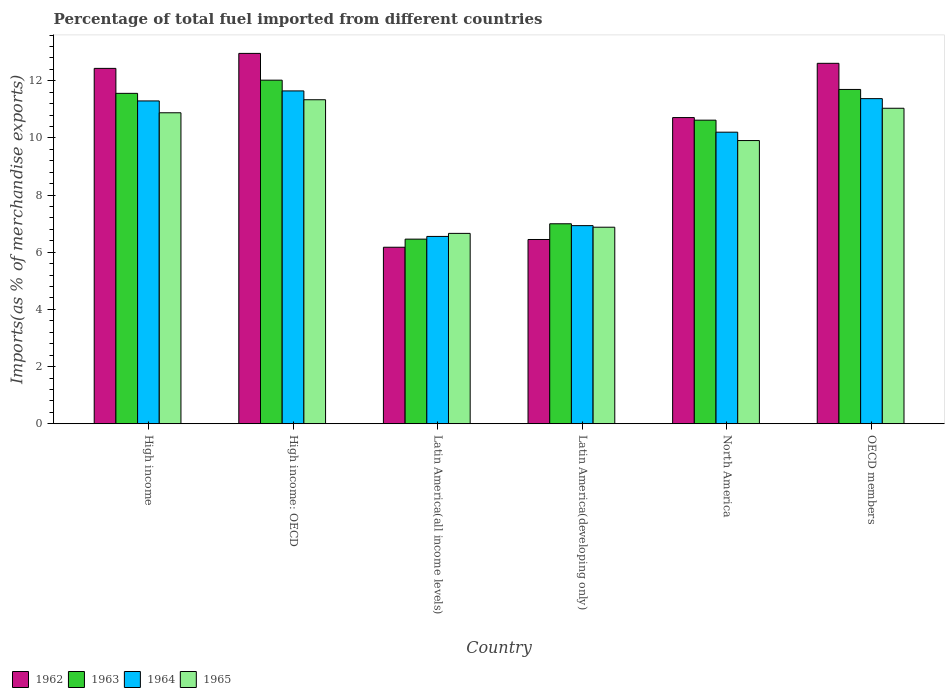Are the number of bars per tick equal to the number of legend labels?
Provide a short and direct response. Yes. How many bars are there on the 6th tick from the left?
Your answer should be compact. 4. How many bars are there on the 4th tick from the right?
Make the answer very short. 4. What is the percentage of imports to different countries in 1964 in High income?
Make the answer very short. 11.29. Across all countries, what is the maximum percentage of imports to different countries in 1964?
Give a very brief answer. 11.64. Across all countries, what is the minimum percentage of imports to different countries in 1962?
Offer a very short reply. 6.17. In which country was the percentage of imports to different countries in 1962 maximum?
Keep it short and to the point. High income: OECD. In which country was the percentage of imports to different countries in 1965 minimum?
Your answer should be compact. Latin America(all income levels). What is the total percentage of imports to different countries in 1963 in the graph?
Your answer should be very brief. 59.35. What is the difference between the percentage of imports to different countries in 1962 in Latin America(all income levels) and that in OECD members?
Your response must be concise. -6.44. What is the difference between the percentage of imports to different countries in 1965 in Latin America(all income levels) and the percentage of imports to different countries in 1962 in OECD members?
Offer a terse response. -5.95. What is the average percentage of imports to different countries in 1962 per country?
Give a very brief answer. 10.22. What is the difference between the percentage of imports to different countries of/in 1963 and percentage of imports to different countries of/in 1965 in OECD members?
Your response must be concise. 0.66. In how many countries, is the percentage of imports to different countries in 1963 greater than 4.8 %?
Your answer should be very brief. 6. What is the ratio of the percentage of imports to different countries in 1963 in Latin America(developing only) to that in North America?
Offer a very short reply. 0.66. Is the difference between the percentage of imports to different countries in 1963 in Latin America(all income levels) and Latin America(developing only) greater than the difference between the percentage of imports to different countries in 1965 in Latin America(all income levels) and Latin America(developing only)?
Offer a very short reply. No. What is the difference between the highest and the second highest percentage of imports to different countries in 1964?
Provide a short and direct response. -0.27. What is the difference between the highest and the lowest percentage of imports to different countries in 1964?
Your response must be concise. 5.09. Is the sum of the percentage of imports to different countries in 1963 in High income: OECD and OECD members greater than the maximum percentage of imports to different countries in 1965 across all countries?
Provide a short and direct response. Yes. Is it the case that in every country, the sum of the percentage of imports to different countries in 1964 and percentage of imports to different countries in 1962 is greater than the sum of percentage of imports to different countries in 1965 and percentage of imports to different countries in 1963?
Keep it short and to the point. No. What does the 2nd bar from the right in Latin America(all income levels) represents?
Provide a succinct answer. 1964. How many countries are there in the graph?
Provide a short and direct response. 6. Are the values on the major ticks of Y-axis written in scientific E-notation?
Offer a very short reply. No. Does the graph contain any zero values?
Offer a very short reply. No. Where does the legend appear in the graph?
Ensure brevity in your answer.  Bottom left. How many legend labels are there?
Give a very brief answer. 4. What is the title of the graph?
Your response must be concise. Percentage of total fuel imported from different countries. Does "1967" appear as one of the legend labels in the graph?
Offer a terse response. No. What is the label or title of the X-axis?
Provide a succinct answer. Country. What is the label or title of the Y-axis?
Provide a short and direct response. Imports(as % of merchandise exports). What is the Imports(as % of merchandise exports) in 1962 in High income?
Offer a terse response. 12.43. What is the Imports(as % of merchandise exports) in 1963 in High income?
Your answer should be very brief. 11.56. What is the Imports(as % of merchandise exports) of 1964 in High income?
Keep it short and to the point. 11.29. What is the Imports(as % of merchandise exports) of 1965 in High income?
Your answer should be compact. 10.88. What is the Imports(as % of merchandise exports) in 1962 in High income: OECD?
Provide a succinct answer. 12.96. What is the Imports(as % of merchandise exports) in 1963 in High income: OECD?
Keep it short and to the point. 12.02. What is the Imports(as % of merchandise exports) of 1964 in High income: OECD?
Make the answer very short. 11.64. What is the Imports(as % of merchandise exports) in 1965 in High income: OECD?
Make the answer very short. 11.34. What is the Imports(as % of merchandise exports) in 1962 in Latin America(all income levels)?
Provide a succinct answer. 6.17. What is the Imports(as % of merchandise exports) of 1963 in Latin America(all income levels)?
Provide a short and direct response. 6.46. What is the Imports(as % of merchandise exports) in 1964 in Latin America(all income levels)?
Give a very brief answer. 6.55. What is the Imports(as % of merchandise exports) in 1965 in Latin America(all income levels)?
Your response must be concise. 6.66. What is the Imports(as % of merchandise exports) of 1962 in Latin America(developing only)?
Keep it short and to the point. 6.45. What is the Imports(as % of merchandise exports) of 1963 in Latin America(developing only)?
Offer a terse response. 7. What is the Imports(as % of merchandise exports) in 1964 in Latin America(developing only)?
Your answer should be compact. 6.93. What is the Imports(as % of merchandise exports) of 1965 in Latin America(developing only)?
Provide a succinct answer. 6.88. What is the Imports(as % of merchandise exports) of 1962 in North America?
Your answer should be compact. 10.71. What is the Imports(as % of merchandise exports) of 1963 in North America?
Offer a terse response. 10.62. What is the Imports(as % of merchandise exports) of 1964 in North America?
Offer a terse response. 10.2. What is the Imports(as % of merchandise exports) of 1965 in North America?
Your answer should be compact. 9.91. What is the Imports(as % of merchandise exports) in 1962 in OECD members?
Ensure brevity in your answer.  12.61. What is the Imports(as % of merchandise exports) of 1963 in OECD members?
Your response must be concise. 11.7. What is the Imports(as % of merchandise exports) of 1964 in OECD members?
Provide a succinct answer. 11.37. What is the Imports(as % of merchandise exports) of 1965 in OECD members?
Your response must be concise. 11.04. Across all countries, what is the maximum Imports(as % of merchandise exports) of 1962?
Your response must be concise. 12.96. Across all countries, what is the maximum Imports(as % of merchandise exports) in 1963?
Provide a succinct answer. 12.02. Across all countries, what is the maximum Imports(as % of merchandise exports) in 1964?
Provide a short and direct response. 11.64. Across all countries, what is the maximum Imports(as % of merchandise exports) of 1965?
Your answer should be very brief. 11.34. Across all countries, what is the minimum Imports(as % of merchandise exports) in 1962?
Give a very brief answer. 6.17. Across all countries, what is the minimum Imports(as % of merchandise exports) of 1963?
Your answer should be very brief. 6.46. Across all countries, what is the minimum Imports(as % of merchandise exports) in 1964?
Offer a very short reply. 6.55. Across all countries, what is the minimum Imports(as % of merchandise exports) in 1965?
Provide a short and direct response. 6.66. What is the total Imports(as % of merchandise exports) of 1962 in the graph?
Provide a short and direct response. 61.33. What is the total Imports(as % of merchandise exports) in 1963 in the graph?
Your answer should be very brief. 59.35. What is the total Imports(as % of merchandise exports) of 1964 in the graph?
Your response must be concise. 58. What is the total Imports(as % of merchandise exports) of 1965 in the graph?
Provide a succinct answer. 56.7. What is the difference between the Imports(as % of merchandise exports) of 1962 in High income and that in High income: OECD?
Provide a short and direct response. -0.52. What is the difference between the Imports(as % of merchandise exports) of 1963 in High income and that in High income: OECD?
Make the answer very short. -0.46. What is the difference between the Imports(as % of merchandise exports) in 1964 in High income and that in High income: OECD?
Make the answer very short. -0.35. What is the difference between the Imports(as % of merchandise exports) of 1965 in High income and that in High income: OECD?
Offer a terse response. -0.46. What is the difference between the Imports(as % of merchandise exports) of 1962 in High income and that in Latin America(all income levels)?
Keep it short and to the point. 6.26. What is the difference between the Imports(as % of merchandise exports) of 1963 in High income and that in Latin America(all income levels)?
Your response must be concise. 5.1. What is the difference between the Imports(as % of merchandise exports) of 1964 in High income and that in Latin America(all income levels)?
Provide a succinct answer. 4.74. What is the difference between the Imports(as % of merchandise exports) of 1965 in High income and that in Latin America(all income levels)?
Make the answer very short. 4.22. What is the difference between the Imports(as % of merchandise exports) of 1962 in High income and that in Latin America(developing only)?
Provide a succinct answer. 5.99. What is the difference between the Imports(as % of merchandise exports) of 1963 in High income and that in Latin America(developing only)?
Keep it short and to the point. 4.56. What is the difference between the Imports(as % of merchandise exports) in 1964 in High income and that in Latin America(developing only)?
Make the answer very short. 4.36. What is the difference between the Imports(as % of merchandise exports) of 1965 in High income and that in Latin America(developing only)?
Your answer should be compact. 4. What is the difference between the Imports(as % of merchandise exports) of 1962 in High income and that in North America?
Provide a short and direct response. 1.72. What is the difference between the Imports(as % of merchandise exports) of 1963 in High income and that in North America?
Provide a short and direct response. 0.94. What is the difference between the Imports(as % of merchandise exports) in 1964 in High income and that in North America?
Your response must be concise. 1.09. What is the difference between the Imports(as % of merchandise exports) in 1965 in High income and that in North America?
Your response must be concise. 0.97. What is the difference between the Imports(as % of merchandise exports) in 1962 in High income and that in OECD members?
Keep it short and to the point. -0.18. What is the difference between the Imports(as % of merchandise exports) in 1963 in High income and that in OECD members?
Offer a very short reply. -0.14. What is the difference between the Imports(as % of merchandise exports) of 1964 in High income and that in OECD members?
Make the answer very short. -0.08. What is the difference between the Imports(as % of merchandise exports) of 1965 in High income and that in OECD members?
Provide a succinct answer. -0.16. What is the difference between the Imports(as % of merchandise exports) in 1962 in High income: OECD and that in Latin America(all income levels)?
Offer a very short reply. 6.78. What is the difference between the Imports(as % of merchandise exports) of 1963 in High income: OECD and that in Latin America(all income levels)?
Provide a short and direct response. 5.56. What is the difference between the Imports(as % of merchandise exports) in 1964 in High income: OECD and that in Latin America(all income levels)?
Your answer should be compact. 5.09. What is the difference between the Imports(as % of merchandise exports) of 1965 in High income: OECD and that in Latin America(all income levels)?
Provide a succinct answer. 4.68. What is the difference between the Imports(as % of merchandise exports) of 1962 in High income: OECD and that in Latin America(developing only)?
Make the answer very short. 6.51. What is the difference between the Imports(as % of merchandise exports) in 1963 in High income: OECD and that in Latin America(developing only)?
Ensure brevity in your answer.  5.02. What is the difference between the Imports(as % of merchandise exports) of 1964 in High income: OECD and that in Latin America(developing only)?
Offer a terse response. 4.71. What is the difference between the Imports(as % of merchandise exports) in 1965 in High income: OECD and that in Latin America(developing only)?
Your response must be concise. 4.46. What is the difference between the Imports(as % of merchandise exports) of 1962 in High income: OECD and that in North America?
Keep it short and to the point. 2.25. What is the difference between the Imports(as % of merchandise exports) of 1963 in High income: OECD and that in North America?
Your answer should be very brief. 1.4. What is the difference between the Imports(as % of merchandise exports) of 1964 in High income: OECD and that in North America?
Provide a short and direct response. 1.44. What is the difference between the Imports(as % of merchandise exports) of 1965 in High income: OECD and that in North America?
Keep it short and to the point. 1.43. What is the difference between the Imports(as % of merchandise exports) of 1962 in High income: OECD and that in OECD members?
Your response must be concise. 0.35. What is the difference between the Imports(as % of merchandise exports) in 1963 in High income: OECD and that in OECD members?
Your answer should be compact. 0.33. What is the difference between the Imports(as % of merchandise exports) of 1964 in High income: OECD and that in OECD members?
Offer a very short reply. 0.27. What is the difference between the Imports(as % of merchandise exports) of 1965 in High income: OECD and that in OECD members?
Your answer should be very brief. 0.3. What is the difference between the Imports(as % of merchandise exports) of 1962 in Latin America(all income levels) and that in Latin America(developing only)?
Offer a very short reply. -0.27. What is the difference between the Imports(as % of merchandise exports) of 1963 in Latin America(all income levels) and that in Latin America(developing only)?
Provide a short and direct response. -0.54. What is the difference between the Imports(as % of merchandise exports) in 1964 in Latin America(all income levels) and that in Latin America(developing only)?
Keep it short and to the point. -0.38. What is the difference between the Imports(as % of merchandise exports) in 1965 in Latin America(all income levels) and that in Latin America(developing only)?
Offer a terse response. -0.22. What is the difference between the Imports(as % of merchandise exports) of 1962 in Latin America(all income levels) and that in North America?
Your answer should be very brief. -4.54. What is the difference between the Imports(as % of merchandise exports) of 1963 in Latin America(all income levels) and that in North America?
Keep it short and to the point. -4.16. What is the difference between the Imports(as % of merchandise exports) of 1964 in Latin America(all income levels) and that in North America?
Offer a very short reply. -3.65. What is the difference between the Imports(as % of merchandise exports) in 1965 in Latin America(all income levels) and that in North America?
Provide a short and direct response. -3.25. What is the difference between the Imports(as % of merchandise exports) in 1962 in Latin America(all income levels) and that in OECD members?
Provide a short and direct response. -6.44. What is the difference between the Imports(as % of merchandise exports) of 1963 in Latin America(all income levels) and that in OECD members?
Your answer should be compact. -5.24. What is the difference between the Imports(as % of merchandise exports) of 1964 in Latin America(all income levels) and that in OECD members?
Make the answer very short. -4.82. What is the difference between the Imports(as % of merchandise exports) of 1965 in Latin America(all income levels) and that in OECD members?
Ensure brevity in your answer.  -4.38. What is the difference between the Imports(as % of merchandise exports) in 1962 in Latin America(developing only) and that in North America?
Keep it short and to the point. -4.27. What is the difference between the Imports(as % of merchandise exports) of 1963 in Latin America(developing only) and that in North America?
Offer a terse response. -3.63. What is the difference between the Imports(as % of merchandise exports) in 1964 in Latin America(developing only) and that in North America?
Your response must be concise. -3.27. What is the difference between the Imports(as % of merchandise exports) in 1965 in Latin America(developing only) and that in North America?
Ensure brevity in your answer.  -3.03. What is the difference between the Imports(as % of merchandise exports) of 1962 in Latin America(developing only) and that in OECD members?
Your answer should be very brief. -6.16. What is the difference between the Imports(as % of merchandise exports) of 1963 in Latin America(developing only) and that in OECD members?
Offer a very short reply. -4.7. What is the difference between the Imports(as % of merchandise exports) of 1964 in Latin America(developing only) and that in OECD members?
Provide a succinct answer. -4.44. What is the difference between the Imports(as % of merchandise exports) in 1965 in Latin America(developing only) and that in OECD members?
Make the answer very short. -4.16. What is the difference between the Imports(as % of merchandise exports) of 1962 in North America and that in OECD members?
Provide a short and direct response. -1.9. What is the difference between the Imports(as % of merchandise exports) of 1963 in North America and that in OECD members?
Ensure brevity in your answer.  -1.07. What is the difference between the Imports(as % of merchandise exports) in 1964 in North America and that in OECD members?
Keep it short and to the point. -1.17. What is the difference between the Imports(as % of merchandise exports) of 1965 in North America and that in OECD members?
Offer a terse response. -1.13. What is the difference between the Imports(as % of merchandise exports) in 1962 in High income and the Imports(as % of merchandise exports) in 1963 in High income: OECD?
Your response must be concise. 0.41. What is the difference between the Imports(as % of merchandise exports) of 1962 in High income and the Imports(as % of merchandise exports) of 1964 in High income: OECD?
Give a very brief answer. 0.79. What is the difference between the Imports(as % of merchandise exports) of 1962 in High income and the Imports(as % of merchandise exports) of 1965 in High income: OECD?
Make the answer very short. 1.1. What is the difference between the Imports(as % of merchandise exports) in 1963 in High income and the Imports(as % of merchandise exports) in 1964 in High income: OECD?
Offer a terse response. -0.09. What is the difference between the Imports(as % of merchandise exports) of 1963 in High income and the Imports(as % of merchandise exports) of 1965 in High income: OECD?
Offer a terse response. 0.22. What is the difference between the Imports(as % of merchandise exports) of 1964 in High income and the Imports(as % of merchandise exports) of 1965 in High income: OECD?
Offer a terse response. -0.04. What is the difference between the Imports(as % of merchandise exports) of 1962 in High income and the Imports(as % of merchandise exports) of 1963 in Latin America(all income levels)?
Your answer should be compact. 5.97. What is the difference between the Imports(as % of merchandise exports) of 1962 in High income and the Imports(as % of merchandise exports) of 1964 in Latin America(all income levels)?
Provide a short and direct response. 5.88. What is the difference between the Imports(as % of merchandise exports) in 1962 in High income and the Imports(as % of merchandise exports) in 1965 in Latin America(all income levels)?
Offer a terse response. 5.77. What is the difference between the Imports(as % of merchandise exports) of 1963 in High income and the Imports(as % of merchandise exports) of 1964 in Latin America(all income levels)?
Offer a very short reply. 5.01. What is the difference between the Imports(as % of merchandise exports) in 1963 in High income and the Imports(as % of merchandise exports) in 1965 in Latin America(all income levels)?
Make the answer very short. 4.9. What is the difference between the Imports(as % of merchandise exports) of 1964 in High income and the Imports(as % of merchandise exports) of 1965 in Latin America(all income levels)?
Your answer should be compact. 4.63. What is the difference between the Imports(as % of merchandise exports) of 1962 in High income and the Imports(as % of merchandise exports) of 1963 in Latin America(developing only)?
Make the answer very short. 5.44. What is the difference between the Imports(as % of merchandise exports) in 1962 in High income and the Imports(as % of merchandise exports) in 1964 in Latin America(developing only)?
Give a very brief answer. 5.5. What is the difference between the Imports(as % of merchandise exports) of 1962 in High income and the Imports(as % of merchandise exports) of 1965 in Latin America(developing only)?
Your answer should be compact. 5.56. What is the difference between the Imports(as % of merchandise exports) of 1963 in High income and the Imports(as % of merchandise exports) of 1964 in Latin America(developing only)?
Ensure brevity in your answer.  4.63. What is the difference between the Imports(as % of merchandise exports) of 1963 in High income and the Imports(as % of merchandise exports) of 1965 in Latin America(developing only)?
Your answer should be compact. 4.68. What is the difference between the Imports(as % of merchandise exports) of 1964 in High income and the Imports(as % of merchandise exports) of 1965 in Latin America(developing only)?
Make the answer very short. 4.42. What is the difference between the Imports(as % of merchandise exports) of 1962 in High income and the Imports(as % of merchandise exports) of 1963 in North America?
Give a very brief answer. 1.81. What is the difference between the Imports(as % of merchandise exports) of 1962 in High income and the Imports(as % of merchandise exports) of 1964 in North America?
Your answer should be very brief. 2.23. What is the difference between the Imports(as % of merchandise exports) of 1962 in High income and the Imports(as % of merchandise exports) of 1965 in North America?
Your answer should be very brief. 2.53. What is the difference between the Imports(as % of merchandise exports) of 1963 in High income and the Imports(as % of merchandise exports) of 1964 in North America?
Your response must be concise. 1.36. What is the difference between the Imports(as % of merchandise exports) in 1963 in High income and the Imports(as % of merchandise exports) in 1965 in North America?
Your answer should be very brief. 1.65. What is the difference between the Imports(as % of merchandise exports) of 1964 in High income and the Imports(as % of merchandise exports) of 1965 in North America?
Your answer should be very brief. 1.39. What is the difference between the Imports(as % of merchandise exports) of 1962 in High income and the Imports(as % of merchandise exports) of 1963 in OECD members?
Keep it short and to the point. 0.74. What is the difference between the Imports(as % of merchandise exports) in 1962 in High income and the Imports(as % of merchandise exports) in 1964 in OECD members?
Give a very brief answer. 1.06. What is the difference between the Imports(as % of merchandise exports) of 1962 in High income and the Imports(as % of merchandise exports) of 1965 in OECD members?
Your answer should be compact. 1.4. What is the difference between the Imports(as % of merchandise exports) in 1963 in High income and the Imports(as % of merchandise exports) in 1964 in OECD members?
Offer a terse response. 0.19. What is the difference between the Imports(as % of merchandise exports) in 1963 in High income and the Imports(as % of merchandise exports) in 1965 in OECD members?
Provide a succinct answer. 0.52. What is the difference between the Imports(as % of merchandise exports) in 1964 in High income and the Imports(as % of merchandise exports) in 1965 in OECD members?
Your answer should be very brief. 0.26. What is the difference between the Imports(as % of merchandise exports) in 1962 in High income: OECD and the Imports(as % of merchandise exports) in 1963 in Latin America(all income levels)?
Make the answer very short. 6.5. What is the difference between the Imports(as % of merchandise exports) in 1962 in High income: OECD and the Imports(as % of merchandise exports) in 1964 in Latin America(all income levels)?
Provide a succinct answer. 6.4. What is the difference between the Imports(as % of merchandise exports) of 1962 in High income: OECD and the Imports(as % of merchandise exports) of 1965 in Latin America(all income levels)?
Make the answer very short. 6.3. What is the difference between the Imports(as % of merchandise exports) of 1963 in High income: OECD and the Imports(as % of merchandise exports) of 1964 in Latin America(all income levels)?
Give a very brief answer. 5.47. What is the difference between the Imports(as % of merchandise exports) of 1963 in High income: OECD and the Imports(as % of merchandise exports) of 1965 in Latin America(all income levels)?
Provide a short and direct response. 5.36. What is the difference between the Imports(as % of merchandise exports) of 1964 in High income: OECD and the Imports(as % of merchandise exports) of 1965 in Latin America(all income levels)?
Give a very brief answer. 4.98. What is the difference between the Imports(as % of merchandise exports) of 1962 in High income: OECD and the Imports(as % of merchandise exports) of 1963 in Latin America(developing only)?
Provide a succinct answer. 5.96. What is the difference between the Imports(as % of merchandise exports) of 1962 in High income: OECD and the Imports(as % of merchandise exports) of 1964 in Latin America(developing only)?
Offer a terse response. 6.03. What is the difference between the Imports(as % of merchandise exports) of 1962 in High income: OECD and the Imports(as % of merchandise exports) of 1965 in Latin America(developing only)?
Provide a short and direct response. 6.08. What is the difference between the Imports(as % of merchandise exports) of 1963 in High income: OECD and the Imports(as % of merchandise exports) of 1964 in Latin America(developing only)?
Give a very brief answer. 5.09. What is the difference between the Imports(as % of merchandise exports) in 1963 in High income: OECD and the Imports(as % of merchandise exports) in 1965 in Latin America(developing only)?
Provide a short and direct response. 5.15. What is the difference between the Imports(as % of merchandise exports) of 1964 in High income: OECD and the Imports(as % of merchandise exports) of 1965 in Latin America(developing only)?
Make the answer very short. 4.77. What is the difference between the Imports(as % of merchandise exports) in 1962 in High income: OECD and the Imports(as % of merchandise exports) in 1963 in North America?
Keep it short and to the point. 2.34. What is the difference between the Imports(as % of merchandise exports) in 1962 in High income: OECD and the Imports(as % of merchandise exports) in 1964 in North America?
Offer a terse response. 2.76. What is the difference between the Imports(as % of merchandise exports) in 1962 in High income: OECD and the Imports(as % of merchandise exports) in 1965 in North America?
Offer a very short reply. 3.05. What is the difference between the Imports(as % of merchandise exports) of 1963 in High income: OECD and the Imports(as % of merchandise exports) of 1964 in North America?
Offer a very short reply. 1.82. What is the difference between the Imports(as % of merchandise exports) in 1963 in High income: OECD and the Imports(as % of merchandise exports) in 1965 in North America?
Give a very brief answer. 2.11. What is the difference between the Imports(as % of merchandise exports) in 1964 in High income: OECD and the Imports(as % of merchandise exports) in 1965 in North America?
Your answer should be very brief. 1.74. What is the difference between the Imports(as % of merchandise exports) in 1962 in High income: OECD and the Imports(as % of merchandise exports) in 1963 in OECD members?
Your answer should be very brief. 1.26. What is the difference between the Imports(as % of merchandise exports) of 1962 in High income: OECD and the Imports(as % of merchandise exports) of 1964 in OECD members?
Offer a very short reply. 1.58. What is the difference between the Imports(as % of merchandise exports) of 1962 in High income: OECD and the Imports(as % of merchandise exports) of 1965 in OECD members?
Offer a terse response. 1.92. What is the difference between the Imports(as % of merchandise exports) of 1963 in High income: OECD and the Imports(as % of merchandise exports) of 1964 in OECD members?
Provide a short and direct response. 0.65. What is the difference between the Imports(as % of merchandise exports) of 1963 in High income: OECD and the Imports(as % of merchandise exports) of 1965 in OECD members?
Ensure brevity in your answer.  0.98. What is the difference between the Imports(as % of merchandise exports) of 1964 in High income: OECD and the Imports(as % of merchandise exports) of 1965 in OECD members?
Ensure brevity in your answer.  0.61. What is the difference between the Imports(as % of merchandise exports) in 1962 in Latin America(all income levels) and the Imports(as % of merchandise exports) in 1963 in Latin America(developing only)?
Keep it short and to the point. -0.82. What is the difference between the Imports(as % of merchandise exports) of 1962 in Latin America(all income levels) and the Imports(as % of merchandise exports) of 1964 in Latin America(developing only)?
Make the answer very short. -0.76. What is the difference between the Imports(as % of merchandise exports) of 1962 in Latin America(all income levels) and the Imports(as % of merchandise exports) of 1965 in Latin America(developing only)?
Provide a short and direct response. -0.7. What is the difference between the Imports(as % of merchandise exports) of 1963 in Latin America(all income levels) and the Imports(as % of merchandise exports) of 1964 in Latin America(developing only)?
Offer a very short reply. -0.47. What is the difference between the Imports(as % of merchandise exports) of 1963 in Latin America(all income levels) and the Imports(as % of merchandise exports) of 1965 in Latin America(developing only)?
Make the answer very short. -0.42. What is the difference between the Imports(as % of merchandise exports) of 1964 in Latin America(all income levels) and the Imports(as % of merchandise exports) of 1965 in Latin America(developing only)?
Make the answer very short. -0.32. What is the difference between the Imports(as % of merchandise exports) of 1962 in Latin America(all income levels) and the Imports(as % of merchandise exports) of 1963 in North America?
Provide a short and direct response. -4.45. What is the difference between the Imports(as % of merchandise exports) of 1962 in Latin America(all income levels) and the Imports(as % of merchandise exports) of 1964 in North America?
Give a very brief answer. -4.03. What is the difference between the Imports(as % of merchandise exports) in 1962 in Latin America(all income levels) and the Imports(as % of merchandise exports) in 1965 in North America?
Provide a succinct answer. -3.73. What is the difference between the Imports(as % of merchandise exports) in 1963 in Latin America(all income levels) and the Imports(as % of merchandise exports) in 1964 in North America?
Your answer should be compact. -3.74. What is the difference between the Imports(as % of merchandise exports) in 1963 in Latin America(all income levels) and the Imports(as % of merchandise exports) in 1965 in North America?
Ensure brevity in your answer.  -3.45. What is the difference between the Imports(as % of merchandise exports) in 1964 in Latin America(all income levels) and the Imports(as % of merchandise exports) in 1965 in North America?
Your response must be concise. -3.35. What is the difference between the Imports(as % of merchandise exports) in 1962 in Latin America(all income levels) and the Imports(as % of merchandise exports) in 1963 in OECD members?
Give a very brief answer. -5.52. What is the difference between the Imports(as % of merchandise exports) of 1962 in Latin America(all income levels) and the Imports(as % of merchandise exports) of 1964 in OECD members?
Make the answer very short. -5.2. What is the difference between the Imports(as % of merchandise exports) in 1962 in Latin America(all income levels) and the Imports(as % of merchandise exports) in 1965 in OECD members?
Give a very brief answer. -4.86. What is the difference between the Imports(as % of merchandise exports) in 1963 in Latin America(all income levels) and the Imports(as % of merchandise exports) in 1964 in OECD members?
Offer a very short reply. -4.92. What is the difference between the Imports(as % of merchandise exports) of 1963 in Latin America(all income levels) and the Imports(as % of merchandise exports) of 1965 in OECD members?
Offer a terse response. -4.58. What is the difference between the Imports(as % of merchandise exports) in 1964 in Latin America(all income levels) and the Imports(as % of merchandise exports) in 1965 in OECD members?
Provide a short and direct response. -4.48. What is the difference between the Imports(as % of merchandise exports) of 1962 in Latin America(developing only) and the Imports(as % of merchandise exports) of 1963 in North America?
Your response must be concise. -4.17. What is the difference between the Imports(as % of merchandise exports) in 1962 in Latin America(developing only) and the Imports(as % of merchandise exports) in 1964 in North America?
Your answer should be compact. -3.75. What is the difference between the Imports(as % of merchandise exports) of 1962 in Latin America(developing only) and the Imports(as % of merchandise exports) of 1965 in North America?
Your response must be concise. -3.46. What is the difference between the Imports(as % of merchandise exports) in 1963 in Latin America(developing only) and the Imports(as % of merchandise exports) in 1964 in North America?
Your answer should be compact. -3.2. What is the difference between the Imports(as % of merchandise exports) of 1963 in Latin America(developing only) and the Imports(as % of merchandise exports) of 1965 in North America?
Keep it short and to the point. -2.91. What is the difference between the Imports(as % of merchandise exports) in 1964 in Latin America(developing only) and the Imports(as % of merchandise exports) in 1965 in North America?
Offer a very short reply. -2.98. What is the difference between the Imports(as % of merchandise exports) of 1962 in Latin America(developing only) and the Imports(as % of merchandise exports) of 1963 in OECD members?
Give a very brief answer. -5.25. What is the difference between the Imports(as % of merchandise exports) of 1962 in Latin America(developing only) and the Imports(as % of merchandise exports) of 1964 in OECD members?
Keep it short and to the point. -4.93. What is the difference between the Imports(as % of merchandise exports) in 1962 in Latin America(developing only) and the Imports(as % of merchandise exports) in 1965 in OECD members?
Your answer should be compact. -4.59. What is the difference between the Imports(as % of merchandise exports) in 1963 in Latin America(developing only) and the Imports(as % of merchandise exports) in 1964 in OECD members?
Your response must be concise. -4.38. What is the difference between the Imports(as % of merchandise exports) of 1963 in Latin America(developing only) and the Imports(as % of merchandise exports) of 1965 in OECD members?
Provide a short and direct response. -4.04. What is the difference between the Imports(as % of merchandise exports) in 1964 in Latin America(developing only) and the Imports(as % of merchandise exports) in 1965 in OECD members?
Keep it short and to the point. -4.11. What is the difference between the Imports(as % of merchandise exports) in 1962 in North America and the Imports(as % of merchandise exports) in 1963 in OECD members?
Give a very brief answer. -0.98. What is the difference between the Imports(as % of merchandise exports) of 1962 in North America and the Imports(as % of merchandise exports) of 1964 in OECD members?
Offer a terse response. -0.66. What is the difference between the Imports(as % of merchandise exports) in 1962 in North America and the Imports(as % of merchandise exports) in 1965 in OECD members?
Your response must be concise. -0.33. What is the difference between the Imports(as % of merchandise exports) of 1963 in North America and the Imports(as % of merchandise exports) of 1964 in OECD members?
Make the answer very short. -0.75. What is the difference between the Imports(as % of merchandise exports) of 1963 in North America and the Imports(as % of merchandise exports) of 1965 in OECD members?
Make the answer very short. -0.42. What is the difference between the Imports(as % of merchandise exports) in 1964 in North America and the Imports(as % of merchandise exports) in 1965 in OECD members?
Your answer should be very brief. -0.84. What is the average Imports(as % of merchandise exports) in 1962 per country?
Keep it short and to the point. 10.22. What is the average Imports(as % of merchandise exports) in 1963 per country?
Your answer should be very brief. 9.89. What is the average Imports(as % of merchandise exports) of 1964 per country?
Offer a terse response. 9.67. What is the average Imports(as % of merchandise exports) of 1965 per country?
Offer a terse response. 9.45. What is the difference between the Imports(as % of merchandise exports) in 1962 and Imports(as % of merchandise exports) in 1963 in High income?
Give a very brief answer. 0.87. What is the difference between the Imports(as % of merchandise exports) of 1962 and Imports(as % of merchandise exports) of 1964 in High income?
Offer a very short reply. 1.14. What is the difference between the Imports(as % of merchandise exports) of 1962 and Imports(as % of merchandise exports) of 1965 in High income?
Offer a terse response. 1.55. What is the difference between the Imports(as % of merchandise exports) of 1963 and Imports(as % of merchandise exports) of 1964 in High income?
Ensure brevity in your answer.  0.27. What is the difference between the Imports(as % of merchandise exports) of 1963 and Imports(as % of merchandise exports) of 1965 in High income?
Your answer should be very brief. 0.68. What is the difference between the Imports(as % of merchandise exports) of 1964 and Imports(as % of merchandise exports) of 1965 in High income?
Offer a very short reply. 0.41. What is the difference between the Imports(as % of merchandise exports) of 1962 and Imports(as % of merchandise exports) of 1963 in High income: OECD?
Ensure brevity in your answer.  0.94. What is the difference between the Imports(as % of merchandise exports) of 1962 and Imports(as % of merchandise exports) of 1964 in High income: OECD?
Your answer should be compact. 1.31. What is the difference between the Imports(as % of merchandise exports) of 1962 and Imports(as % of merchandise exports) of 1965 in High income: OECD?
Offer a terse response. 1.62. What is the difference between the Imports(as % of merchandise exports) of 1963 and Imports(as % of merchandise exports) of 1964 in High income: OECD?
Offer a terse response. 0.38. What is the difference between the Imports(as % of merchandise exports) of 1963 and Imports(as % of merchandise exports) of 1965 in High income: OECD?
Make the answer very short. 0.69. What is the difference between the Imports(as % of merchandise exports) in 1964 and Imports(as % of merchandise exports) in 1965 in High income: OECD?
Provide a short and direct response. 0.31. What is the difference between the Imports(as % of merchandise exports) in 1962 and Imports(as % of merchandise exports) in 1963 in Latin America(all income levels)?
Provide a succinct answer. -0.28. What is the difference between the Imports(as % of merchandise exports) of 1962 and Imports(as % of merchandise exports) of 1964 in Latin America(all income levels)?
Ensure brevity in your answer.  -0.38. What is the difference between the Imports(as % of merchandise exports) of 1962 and Imports(as % of merchandise exports) of 1965 in Latin America(all income levels)?
Keep it short and to the point. -0.48. What is the difference between the Imports(as % of merchandise exports) of 1963 and Imports(as % of merchandise exports) of 1964 in Latin America(all income levels)?
Offer a very short reply. -0.09. What is the difference between the Imports(as % of merchandise exports) of 1963 and Imports(as % of merchandise exports) of 1965 in Latin America(all income levels)?
Offer a very short reply. -0.2. What is the difference between the Imports(as % of merchandise exports) of 1964 and Imports(as % of merchandise exports) of 1965 in Latin America(all income levels)?
Keep it short and to the point. -0.11. What is the difference between the Imports(as % of merchandise exports) of 1962 and Imports(as % of merchandise exports) of 1963 in Latin America(developing only)?
Offer a very short reply. -0.55. What is the difference between the Imports(as % of merchandise exports) in 1962 and Imports(as % of merchandise exports) in 1964 in Latin America(developing only)?
Offer a terse response. -0.48. What is the difference between the Imports(as % of merchandise exports) of 1962 and Imports(as % of merchandise exports) of 1965 in Latin America(developing only)?
Make the answer very short. -0.43. What is the difference between the Imports(as % of merchandise exports) in 1963 and Imports(as % of merchandise exports) in 1964 in Latin America(developing only)?
Give a very brief answer. 0.07. What is the difference between the Imports(as % of merchandise exports) in 1963 and Imports(as % of merchandise exports) in 1965 in Latin America(developing only)?
Your answer should be compact. 0.12. What is the difference between the Imports(as % of merchandise exports) of 1964 and Imports(as % of merchandise exports) of 1965 in Latin America(developing only)?
Offer a very short reply. 0.06. What is the difference between the Imports(as % of merchandise exports) of 1962 and Imports(as % of merchandise exports) of 1963 in North America?
Make the answer very short. 0.09. What is the difference between the Imports(as % of merchandise exports) in 1962 and Imports(as % of merchandise exports) in 1964 in North America?
Your answer should be compact. 0.51. What is the difference between the Imports(as % of merchandise exports) of 1962 and Imports(as % of merchandise exports) of 1965 in North America?
Make the answer very short. 0.8. What is the difference between the Imports(as % of merchandise exports) in 1963 and Imports(as % of merchandise exports) in 1964 in North America?
Offer a very short reply. 0.42. What is the difference between the Imports(as % of merchandise exports) in 1963 and Imports(as % of merchandise exports) in 1965 in North America?
Your answer should be very brief. 0.71. What is the difference between the Imports(as % of merchandise exports) of 1964 and Imports(as % of merchandise exports) of 1965 in North America?
Provide a succinct answer. 0.29. What is the difference between the Imports(as % of merchandise exports) of 1962 and Imports(as % of merchandise exports) of 1963 in OECD members?
Keep it short and to the point. 0.91. What is the difference between the Imports(as % of merchandise exports) in 1962 and Imports(as % of merchandise exports) in 1964 in OECD members?
Your response must be concise. 1.24. What is the difference between the Imports(as % of merchandise exports) in 1962 and Imports(as % of merchandise exports) in 1965 in OECD members?
Give a very brief answer. 1.57. What is the difference between the Imports(as % of merchandise exports) of 1963 and Imports(as % of merchandise exports) of 1964 in OECD members?
Keep it short and to the point. 0.32. What is the difference between the Imports(as % of merchandise exports) in 1963 and Imports(as % of merchandise exports) in 1965 in OECD members?
Your answer should be very brief. 0.66. What is the difference between the Imports(as % of merchandise exports) of 1964 and Imports(as % of merchandise exports) of 1965 in OECD members?
Provide a short and direct response. 0.34. What is the ratio of the Imports(as % of merchandise exports) in 1962 in High income to that in High income: OECD?
Provide a short and direct response. 0.96. What is the ratio of the Imports(as % of merchandise exports) of 1963 in High income to that in High income: OECD?
Offer a terse response. 0.96. What is the ratio of the Imports(as % of merchandise exports) of 1964 in High income to that in High income: OECD?
Ensure brevity in your answer.  0.97. What is the ratio of the Imports(as % of merchandise exports) in 1965 in High income to that in High income: OECD?
Your answer should be very brief. 0.96. What is the ratio of the Imports(as % of merchandise exports) of 1962 in High income to that in Latin America(all income levels)?
Provide a succinct answer. 2.01. What is the ratio of the Imports(as % of merchandise exports) in 1963 in High income to that in Latin America(all income levels)?
Provide a short and direct response. 1.79. What is the ratio of the Imports(as % of merchandise exports) in 1964 in High income to that in Latin America(all income levels)?
Offer a terse response. 1.72. What is the ratio of the Imports(as % of merchandise exports) of 1965 in High income to that in Latin America(all income levels)?
Keep it short and to the point. 1.63. What is the ratio of the Imports(as % of merchandise exports) in 1962 in High income to that in Latin America(developing only)?
Provide a succinct answer. 1.93. What is the ratio of the Imports(as % of merchandise exports) of 1963 in High income to that in Latin America(developing only)?
Make the answer very short. 1.65. What is the ratio of the Imports(as % of merchandise exports) in 1964 in High income to that in Latin America(developing only)?
Offer a very short reply. 1.63. What is the ratio of the Imports(as % of merchandise exports) of 1965 in High income to that in Latin America(developing only)?
Provide a succinct answer. 1.58. What is the ratio of the Imports(as % of merchandise exports) in 1962 in High income to that in North America?
Make the answer very short. 1.16. What is the ratio of the Imports(as % of merchandise exports) in 1963 in High income to that in North America?
Your answer should be very brief. 1.09. What is the ratio of the Imports(as % of merchandise exports) of 1964 in High income to that in North America?
Keep it short and to the point. 1.11. What is the ratio of the Imports(as % of merchandise exports) of 1965 in High income to that in North America?
Provide a short and direct response. 1.1. What is the ratio of the Imports(as % of merchandise exports) of 1962 in High income to that in OECD members?
Offer a terse response. 0.99. What is the ratio of the Imports(as % of merchandise exports) of 1963 in High income to that in OECD members?
Provide a short and direct response. 0.99. What is the ratio of the Imports(as % of merchandise exports) of 1965 in High income to that in OECD members?
Offer a very short reply. 0.99. What is the ratio of the Imports(as % of merchandise exports) of 1962 in High income: OECD to that in Latin America(all income levels)?
Offer a very short reply. 2.1. What is the ratio of the Imports(as % of merchandise exports) of 1963 in High income: OECD to that in Latin America(all income levels)?
Provide a succinct answer. 1.86. What is the ratio of the Imports(as % of merchandise exports) in 1964 in High income: OECD to that in Latin America(all income levels)?
Give a very brief answer. 1.78. What is the ratio of the Imports(as % of merchandise exports) of 1965 in High income: OECD to that in Latin America(all income levels)?
Your answer should be compact. 1.7. What is the ratio of the Imports(as % of merchandise exports) of 1962 in High income: OECD to that in Latin America(developing only)?
Make the answer very short. 2.01. What is the ratio of the Imports(as % of merchandise exports) of 1963 in High income: OECD to that in Latin America(developing only)?
Your answer should be very brief. 1.72. What is the ratio of the Imports(as % of merchandise exports) in 1964 in High income: OECD to that in Latin America(developing only)?
Offer a terse response. 1.68. What is the ratio of the Imports(as % of merchandise exports) in 1965 in High income: OECD to that in Latin America(developing only)?
Give a very brief answer. 1.65. What is the ratio of the Imports(as % of merchandise exports) of 1962 in High income: OECD to that in North America?
Make the answer very short. 1.21. What is the ratio of the Imports(as % of merchandise exports) of 1963 in High income: OECD to that in North America?
Your response must be concise. 1.13. What is the ratio of the Imports(as % of merchandise exports) in 1964 in High income: OECD to that in North America?
Provide a short and direct response. 1.14. What is the ratio of the Imports(as % of merchandise exports) of 1965 in High income: OECD to that in North America?
Offer a terse response. 1.14. What is the ratio of the Imports(as % of merchandise exports) of 1962 in High income: OECD to that in OECD members?
Offer a very short reply. 1.03. What is the ratio of the Imports(as % of merchandise exports) of 1963 in High income: OECD to that in OECD members?
Your answer should be very brief. 1.03. What is the ratio of the Imports(as % of merchandise exports) in 1964 in High income: OECD to that in OECD members?
Give a very brief answer. 1.02. What is the ratio of the Imports(as % of merchandise exports) of 1965 in High income: OECD to that in OECD members?
Give a very brief answer. 1.03. What is the ratio of the Imports(as % of merchandise exports) of 1962 in Latin America(all income levels) to that in Latin America(developing only)?
Offer a terse response. 0.96. What is the ratio of the Imports(as % of merchandise exports) of 1963 in Latin America(all income levels) to that in Latin America(developing only)?
Provide a short and direct response. 0.92. What is the ratio of the Imports(as % of merchandise exports) of 1964 in Latin America(all income levels) to that in Latin America(developing only)?
Your answer should be very brief. 0.95. What is the ratio of the Imports(as % of merchandise exports) of 1965 in Latin America(all income levels) to that in Latin America(developing only)?
Offer a terse response. 0.97. What is the ratio of the Imports(as % of merchandise exports) in 1962 in Latin America(all income levels) to that in North America?
Offer a very short reply. 0.58. What is the ratio of the Imports(as % of merchandise exports) in 1963 in Latin America(all income levels) to that in North America?
Your response must be concise. 0.61. What is the ratio of the Imports(as % of merchandise exports) of 1964 in Latin America(all income levels) to that in North America?
Your answer should be very brief. 0.64. What is the ratio of the Imports(as % of merchandise exports) in 1965 in Latin America(all income levels) to that in North America?
Provide a short and direct response. 0.67. What is the ratio of the Imports(as % of merchandise exports) of 1962 in Latin America(all income levels) to that in OECD members?
Keep it short and to the point. 0.49. What is the ratio of the Imports(as % of merchandise exports) of 1963 in Latin America(all income levels) to that in OECD members?
Give a very brief answer. 0.55. What is the ratio of the Imports(as % of merchandise exports) in 1964 in Latin America(all income levels) to that in OECD members?
Your answer should be compact. 0.58. What is the ratio of the Imports(as % of merchandise exports) of 1965 in Latin America(all income levels) to that in OECD members?
Ensure brevity in your answer.  0.6. What is the ratio of the Imports(as % of merchandise exports) of 1962 in Latin America(developing only) to that in North America?
Ensure brevity in your answer.  0.6. What is the ratio of the Imports(as % of merchandise exports) of 1963 in Latin America(developing only) to that in North America?
Your response must be concise. 0.66. What is the ratio of the Imports(as % of merchandise exports) of 1964 in Latin America(developing only) to that in North America?
Give a very brief answer. 0.68. What is the ratio of the Imports(as % of merchandise exports) of 1965 in Latin America(developing only) to that in North America?
Ensure brevity in your answer.  0.69. What is the ratio of the Imports(as % of merchandise exports) in 1962 in Latin America(developing only) to that in OECD members?
Ensure brevity in your answer.  0.51. What is the ratio of the Imports(as % of merchandise exports) in 1963 in Latin America(developing only) to that in OECD members?
Your answer should be very brief. 0.6. What is the ratio of the Imports(as % of merchandise exports) in 1964 in Latin America(developing only) to that in OECD members?
Your answer should be very brief. 0.61. What is the ratio of the Imports(as % of merchandise exports) of 1965 in Latin America(developing only) to that in OECD members?
Make the answer very short. 0.62. What is the ratio of the Imports(as % of merchandise exports) of 1962 in North America to that in OECD members?
Keep it short and to the point. 0.85. What is the ratio of the Imports(as % of merchandise exports) in 1963 in North America to that in OECD members?
Provide a short and direct response. 0.91. What is the ratio of the Imports(as % of merchandise exports) of 1964 in North America to that in OECD members?
Your answer should be compact. 0.9. What is the ratio of the Imports(as % of merchandise exports) of 1965 in North America to that in OECD members?
Your answer should be compact. 0.9. What is the difference between the highest and the second highest Imports(as % of merchandise exports) of 1962?
Ensure brevity in your answer.  0.35. What is the difference between the highest and the second highest Imports(as % of merchandise exports) in 1963?
Keep it short and to the point. 0.33. What is the difference between the highest and the second highest Imports(as % of merchandise exports) in 1964?
Provide a short and direct response. 0.27. What is the difference between the highest and the second highest Imports(as % of merchandise exports) in 1965?
Offer a terse response. 0.3. What is the difference between the highest and the lowest Imports(as % of merchandise exports) of 1962?
Make the answer very short. 6.78. What is the difference between the highest and the lowest Imports(as % of merchandise exports) of 1963?
Keep it short and to the point. 5.56. What is the difference between the highest and the lowest Imports(as % of merchandise exports) in 1964?
Your answer should be compact. 5.09. What is the difference between the highest and the lowest Imports(as % of merchandise exports) of 1965?
Give a very brief answer. 4.68. 